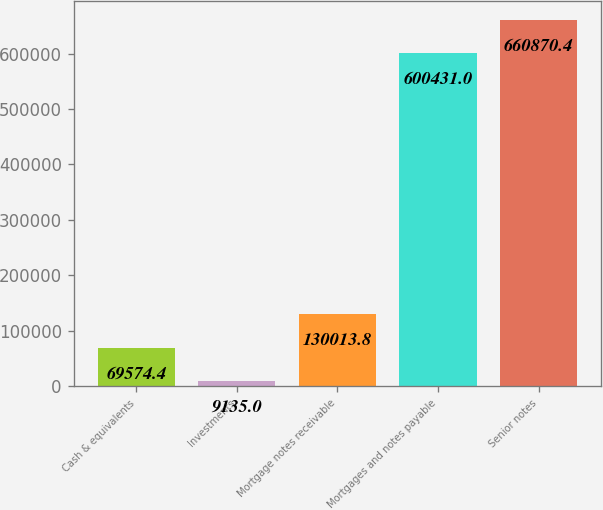<chart> <loc_0><loc_0><loc_500><loc_500><bar_chart><fcel>Cash & equivalents<fcel>Investments<fcel>Mortgage notes receivable<fcel>Mortgages and notes payable<fcel>Senior notes<nl><fcel>69574.4<fcel>9135<fcel>130014<fcel>600431<fcel>660870<nl></chart> 